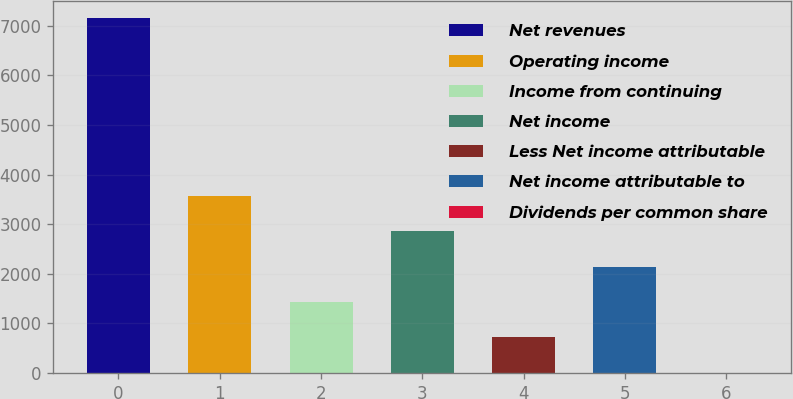Convert chart to OTSL. <chart><loc_0><loc_0><loc_500><loc_500><bar_chart><fcel>Net revenues<fcel>Operating income<fcel>Income from continuing<fcel>Net income<fcel>Less Net income attributable<fcel>Net income attributable to<fcel>Dividends per common share<nl><fcel>7146<fcel>3573.6<fcel>1430.16<fcel>2859.12<fcel>715.68<fcel>2144.64<fcel>1.2<nl></chart> 